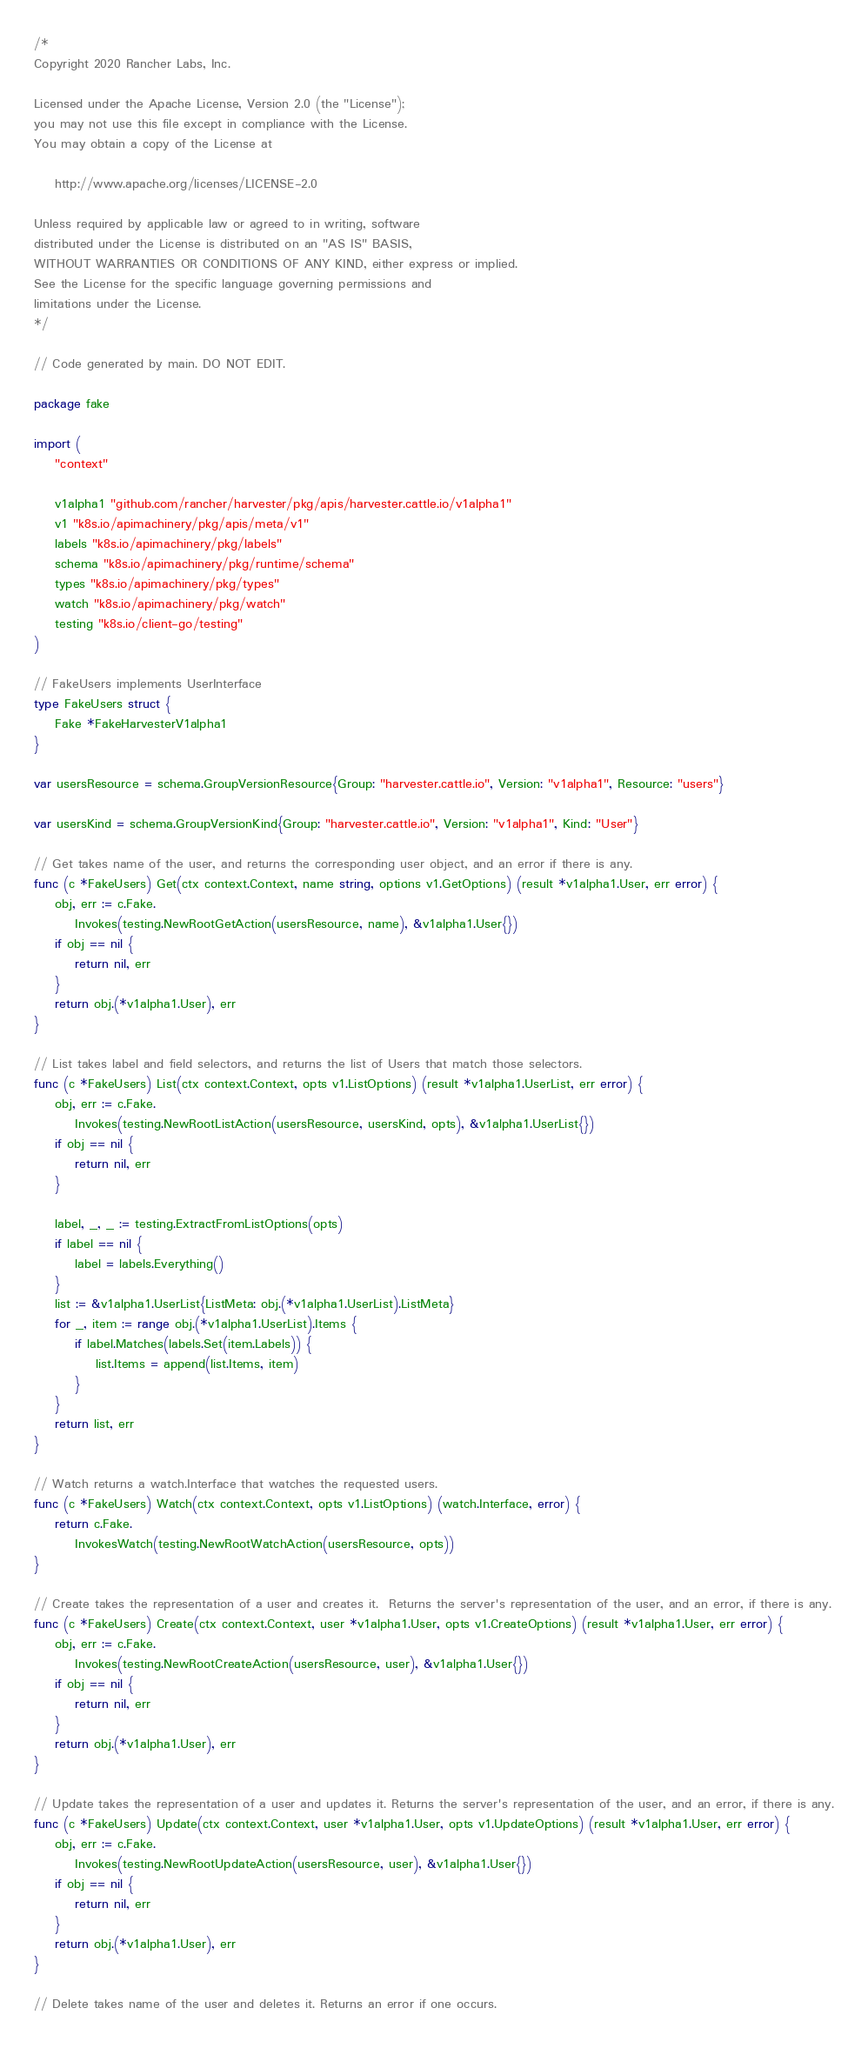<code> <loc_0><loc_0><loc_500><loc_500><_Go_>/*
Copyright 2020 Rancher Labs, Inc.

Licensed under the Apache License, Version 2.0 (the "License");
you may not use this file except in compliance with the License.
You may obtain a copy of the License at

    http://www.apache.org/licenses/LICENSE-2.0

Unless required by applicable law or agreed to in writing, software
distributed under the License is distributed on an "AS IS" BASIS,
WITHOUT WARRANTIES OR CONDITIONS OF ANY KIND, either express or implied.
See the License for the specific language governing permissions and
limitations under the License.
*/

// Code generated by main. DO NOT EDIT.

package fake

import (
	"context"

	v1alpha1 "github.com/rancher/harvester/pkg/apis/harvester.cattle.io/v1alpha1"
	v1 "k8s.io/apimachinery/pkg/apis/meta/v1"
	labels "k8s.io/apimachinery/pkg/labels"
	schema "k8s.io/apimachinery/pkg/runtime/schema"
	types "k8s.io/apimachinery/pkg/types"
	watch "k8s.io/apimachinery/pkg/watch"
	testing "k8s.io/client-go/testing"
)

// FakeUsers implements UserInterface
type FakeUsers struct {
	Fake *FakeHarvesterV1alpha1
}

var usersResource = schema.GroupVersionResource{Group: "harvester.cattle.io", Version: "v1alpha1", Resource: "users"}

var usersKind = schema.GroupVersionKind{Group: "harvester.cattle.io", Version: "v1alpha1", Kind: "User"}

// Get takes name of the user, and returns the corresponding user object, and an error if there is any.
func (c *FakeUsers) Get(ctx context.Context, name string, options v1.GetOptions) (result *v1alpha1.User, err error) {
	obj, err := c.Fake.
		Invokes(testing.NewRootGetAction(usersResource, name), &v1alpha1.User{})
	if obj == nil {
		return nil, err
	}
	return obj.(*v1alpha1.User), err
}

// List takes label and field selectors, and returns the list of Users that match those selectors.
func (c *FakeUsers) List(ctx context.Context, opts v1.ListOptions) (result *v1alpha1.UserList, err error) {
	obj, err := c.Fake.
		Invokes(testing.NewRootListAction(usersResource, usersKind, opts), &v1alpha1.UserList{})
	if obj == nil {
		return nil, err
	}

	label, _, _ := testing.ExtractFromListOptions(opts)
	if label == nil {
		label = labels.Everything()
	}
	list := &v1alpha1.UserList{ListMeta: obj.(*v1alpha1.UserList).ListMeta}
	for _, item := range obj.(*v1alpha1.UserList).Items {
		if label.Matches(labels.Set(item.Labels)) {
			list.Items = append(list.Items, item)
		}
	}
	return list, err
}

// Watch returns a watch.Interface that watches the requested users.
func (c *FakeUsers) Watch(ctx context.Context, opts v1.ListOptions) (watch.Interface, error) {
	return c.Fake.
		InvokesWatch(testing.NewRootWatchAction(usersResource, opts))
}

// Create takes the representation of a user and creates it.  Returns the server's representation of the user, and an error, if there is any.
func (c *FakeUsers) Create(ctx context.Context, user *v1alpha1.User, opts v1.CreateOptions) (result *v1alpha1.User, err error) {
	obj, err := c.Fake.
		Invokes(testing.NewRootCreateAction(usersResource, user), &v1alpha1.User{})
	if obj == nil {
		return nil, err
	}
	return obj.(*v1alpha1.User), err
}

// Update takes the representation of a user and updates it. Returns the server's representation of the user, and an error, if there is any.
func (c *FakeUsers) Update(ctx context.Context, user *v1alpha1.User, opts v1.UpdateOptions) (result *v1alpha1.User, err error) {
	obj, err := c.Fake.
		Invokes(testing.NewRootUpdateAction(usersResource, user), &v1alpha1.User{})
	if obj == nil {
		return nil, err
	}
	return obj.(*v1alpha1.User), err
}

// Delete takes name of the user and deletes it. Returns an error if one occurs.</code> 